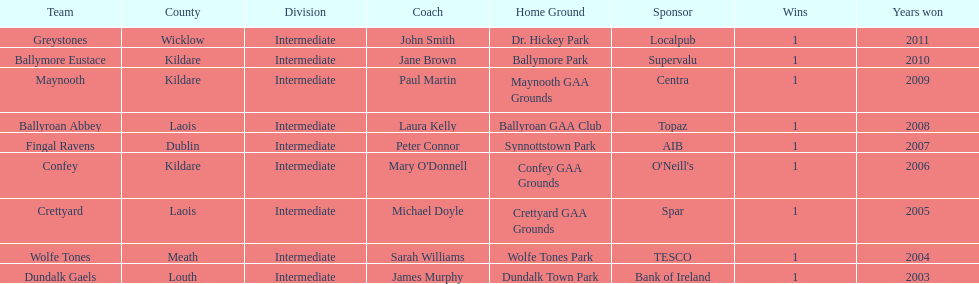What is the number of wins for each team 1. 